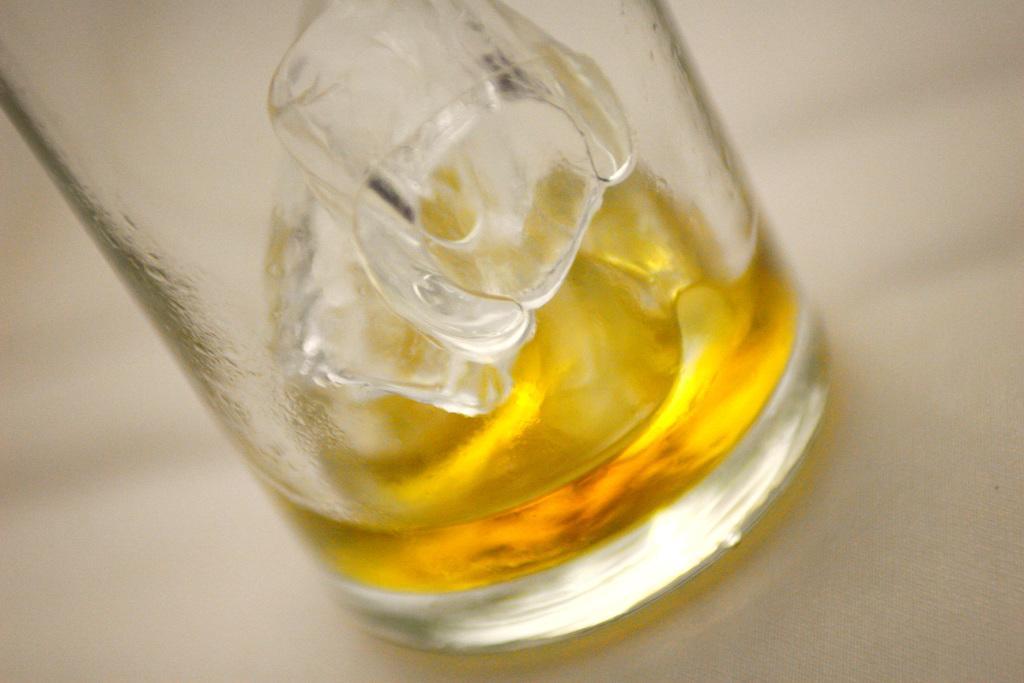Can you describe this image briefly? In this image there is a table with a glass on it and there are two ice cubes and juice in the glass. 